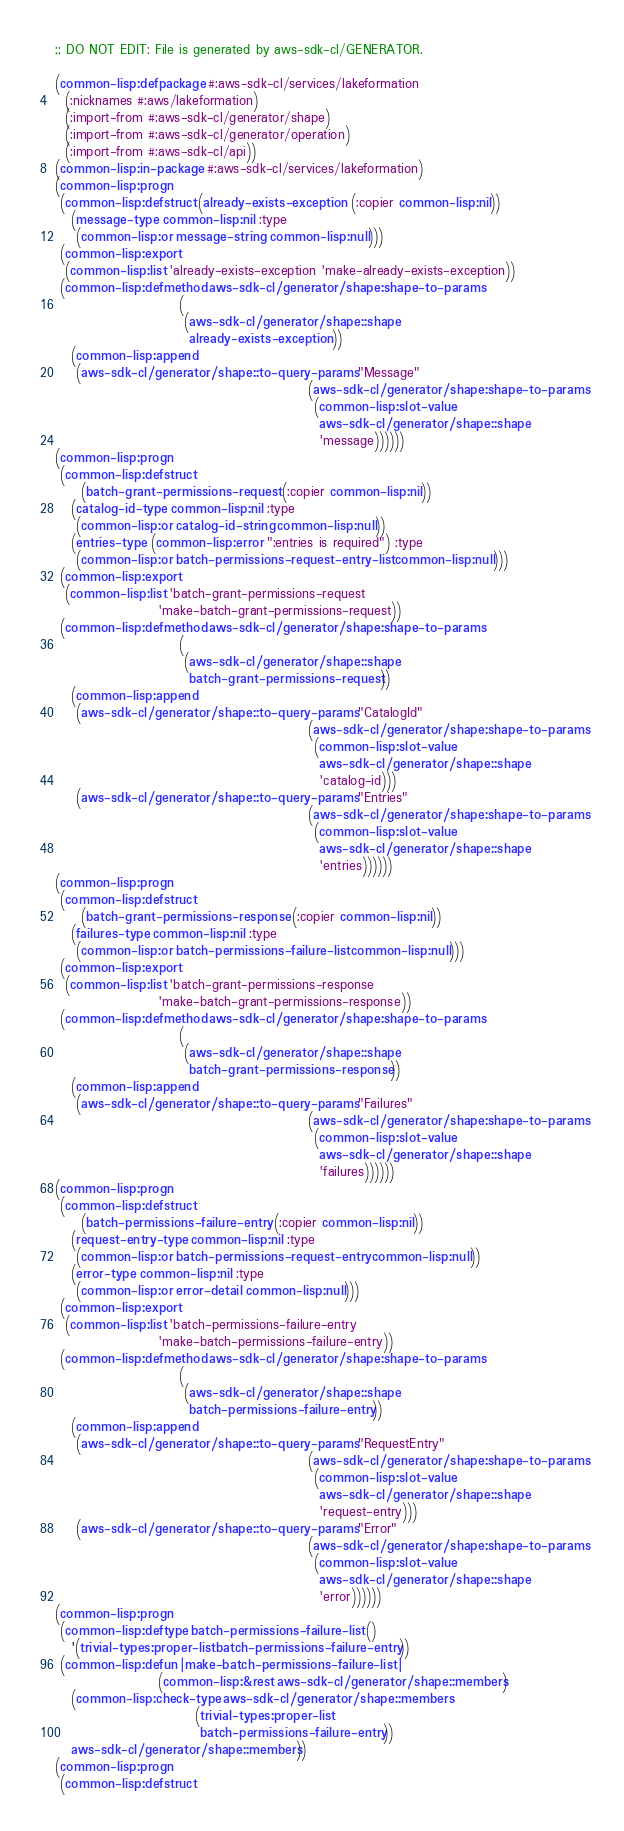Convert code to text. <code><loc_0><loc_0><loc_500><loc_500><_Lisp_>;; DO NOT EDIT: File is generated by aws-sdk-cl/GENERATOR.

(common-lisp:defpackage #:aws-sdk-cl/services/lakeformation
  (:nicknames #:aws/lakeformation)
  (:import-from #:aws-sdk-cl/generator/shape)
  (:import-from #:aws-sdk-cl/generator/operation)
  (:import-from #:aws-sdk-cl/api))
(common-lisp:in-package #:aws-sdk-cl/services/lakeformation)
(common-lisp:progn
 (common-lisp:defstruct (already-exists-exception (:copier common-lisp:nil))
   (message-type common-lisp:nil :type
    (common-lisp:or message-string common-lisp:null)))
 (common-lisp:export
  (common-lisp:list 'already-exists-exception 'make-already-exists-exception))
 (common-lisp:defmethod aws-sdk-cl/generator/shape:shape-to-params
                        (
                         (aws-sdk-cl/generator/shape::shape
                          already-exists-exception))
   (common-lisp:append
    (aws-sdk-cl/generator/shape::to-query-params "Message"
                                                 (aws-sdk-cl/generator/shape:shape-to-params
                                                  (common-lisp:slot-value
                                                   aws-sdk-cl/generator/shape::shape
                                                   'message))))))
(common-lisp:progn
 (common-lisp:defstruct
     (batch-grant-permissions-request (:copier common-lisp:nil))
   (catalog-id-type common-lisp:nil :type
    (common-lisp:or catalog-id-string common-lisp:null))
   (entries-type (common-lisp:error ":entries is required") :type
    (common-lisp:or batch-permissions-request-entry-list common-lisp:null)))
 (common-lisp:export
  (common-lisp:list 'batch-grant-permissions-request
                    'make-batch-grant-permissions-request))
 (common-lisp:defmethod aws-sdk-cl/generator/shape:shape-to-params
                        (
                         (aws-sdk-cl/generator/shape::shape
                          batch-grant-permissions-request))
   (common-lisp:append
    (aws-sdk-cl/generator/shape::to-query-params "CatalogId"
                                                 (aws-sdk-cl/generator/shape:shape-to-params
                                                  (common-lisp:slot-value
                                                   aws-sdk-cl/generator/shape::shape
                                                   'catalog-id)))
    (aws-sdk-cl/generator/shape::to-query-params "Entries"
                                                 (aws-sdk-cl/generator/shape:shape-to-params
                                                  (common-lisp:slot-value
                                                   aws-sdk-cl/generator/shape::shape
                                                   'entries))))))
(common-lisp:progn
 (common-lisp:defstruct
     (batch-grant-permissions-response (:copier common-lisp:nil))
   (failures-type common-lisp:nil :type
    (common-lisp:or batch-permissions-failure-list common-lisp:null)))
 (common-lisp:export
  (common-lisp:list 'batch-grant-permissions-response
                    'make-batch-grant-permissions-response))
 (common-lisp:defmethod aws-sdk-cl/generator/shape:shape-to-params
                        (
                         (aws-sdk-cl/generator/shape::shape
                          batch-grant-permissions-response))
   (common-lisp:append
    (aws-sdk-cl/generator/shape::to-query-params "Failures"
                                                 (aws-sdk-cl/generator/shape:shape-to-params
                                                  (common-lisp:slot-value
                                                   aws-sdk-cl/generator/shape::shape
                                                   'failures))))))
(common-lisp:progn
 (common-lisp:defstruct
     (batch-permissions-failure-entry (:copier common-lisp:nil))
   (request-entry-type common-lisp:nil :type
    (common-lisp:or batch-permissions-request-entry common-lisp:null))
   (error-type common-lisp:nil :type
    (common-lisp:or error-detail common-lisp:null)))
 (common-lisp:export
  (common-lisp:list 'batch-permissions-failure-entry
                    'make-batch-permissions-failure-entry))
 (common-lisp:defmethod aws-sdk-cl/generator/shape:shape-to-params
                        (
                         (aws-sdk-cl/generator/shape::shape
                          batch-permissions-failure-entry))
   (common-lisp:append
    (aws-sdk-cl/generator/shape::to-query-params "RequestEntry"
                                                 (aws-sdk-cl/generator/shape:shape-to-params
                                                  (common-lisp:slot-value
                                                   aws-sdk-cl/generator/shape::shape
                                                   'request-entry)))
    (aws-sdk-cl/generator/shape::to-query-params "Error"
                                                 (aws-sdk-cl/generator/shape:shape-to-params
                                                  (common-lisp:slot-value
                                                   aws-sdk-cl/generator/shape::shape
                                                   'error))))))
(common-lisp:progn
 (common-lisp:deftype batch-permissions-failure-list ()
   '(trivial-types:proper-list batch-permissions-failure-entry))
 (common-lisp:defun |make-batch-permissions-failure-list|
                    (common-lisp:&rest aws-sdk-cl/generator/shape::members)
   (common-lisp:check-type aws-sdk-cl/generator/shape::members
                           (trivial-types:proper-list
                            batch-permissions-failure-entry))
   aws-sdk-cl/generator/shape::members))
(common-lisp:progn
 (common-lisp:defstruct</code> 